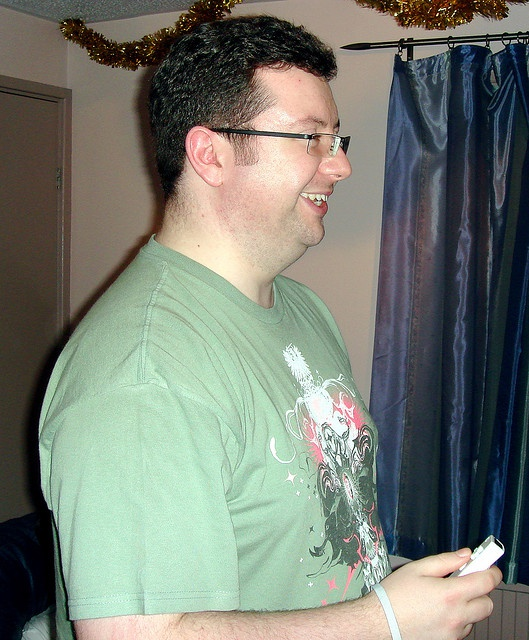Describe the objects in this image and their specific colors. I can see people in gray, aquamarine, beige, and darkgray tones and remote in gray, white, darkgray, black, and tan tones in this image. 